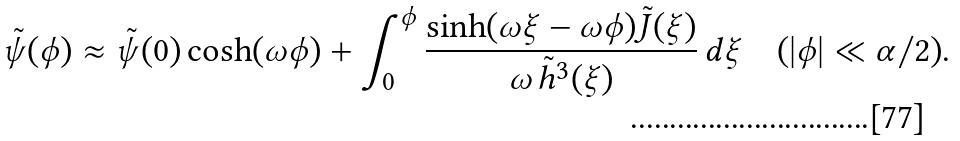<formula> <loc_0><loc_0><loc_500><loc_500>\tilde { \psi } ( \phi ) \approx \tilde { \psi } ( 0 ) \cosh ( \omega \phi ) + \int _ { 0 } ^ { \phi } \frac { \sinh ( \omega \xi - \omega \phi ) \tilde { J } ( \xi ) } { \omega \, \tilde { h } ^ { 3 } ( \xi ) } \, d \xi \quad ( | \phi | \ll \alpha / 2 ) .</formula> 